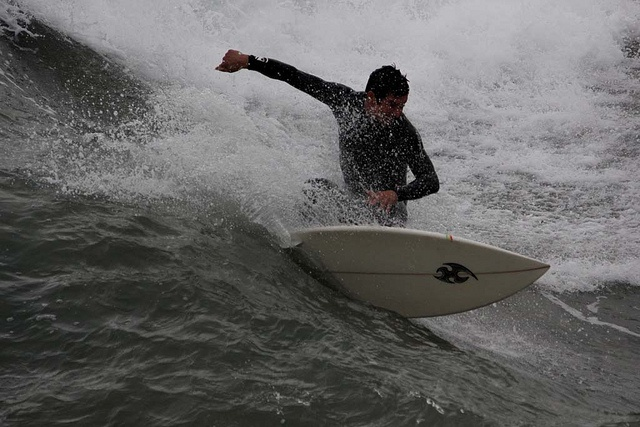Describe the objects in this image and their specific colors. I can see people in gray, black, darkgray, and maroon tones and surfboard in gray and black tones in this image. 